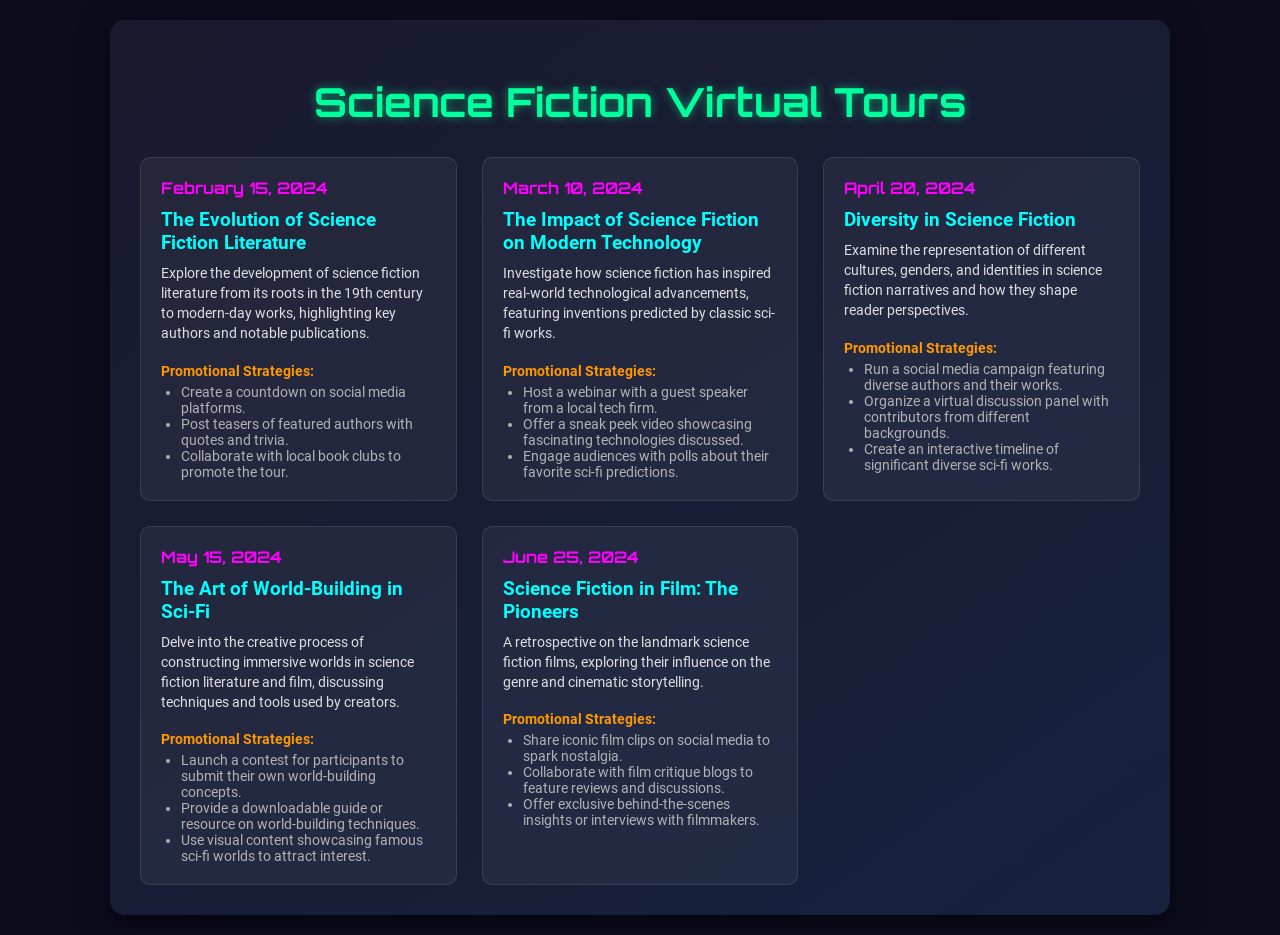What is the date of the first virtual tour? The first virtual tour is scheduled for February 15, 2024, as mentioned in the document.
Answer: February 15, 2024 What is the topic of the tour on March 10, 2024? The topic of the tour on March 10, 2024, is about the impact of science fiction on modern technology.
Answer: The Impact of Science Fiction on Modern Technology How many virtual tours are scheduled in total? The document lists five distinct virtual tours scheduled.
Answer: Five What promotional strategy involves collaborating with local book clubs? This strategy is associated with the tour on February 15, 2024, focusing on the evolution of science fiction literature.
Answer: Collaborate with local book clubs Which tour focuses on diversity in science fiction? The tour covering diversity is scheduled for April 20, 2024.
Answer: April 20, 2024 Name a promotional strategy for the tour about world-building. One promotional strategy is launching a contest for participants to submit their own world-building concepts.
Answer: Launch a contest What is the main focus of the tour on June 25, 2024? The main focus is a retrospective on landmark science fiction films and their influence.
Answer: Science Fiction in Film: The Pioneers Which strategy includes sharing iconic film clips? This strategy is for the June 25, 2024, tour discussing science fiction in film.
Answer: Share iconic film clips 